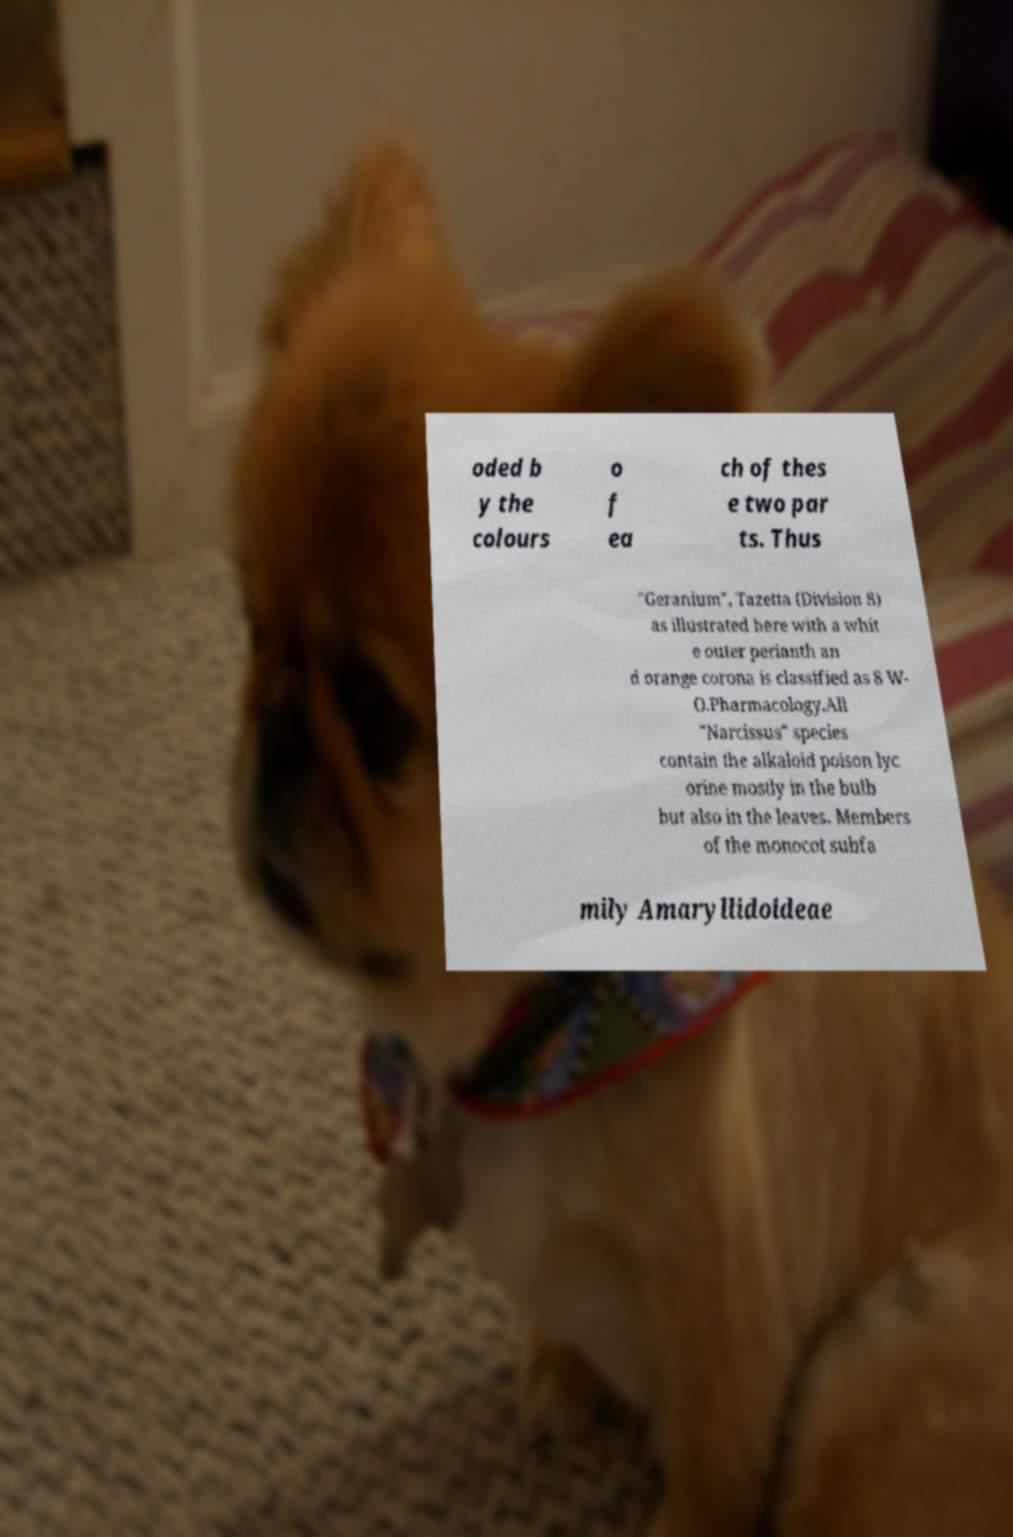Please identify and transcribe the text found in this image. oded b y the colours o f ea ch of thes e two par ts. Thus "Geranium", Tazetta (Division 8) as illustrated here with a whit e outer perianth an d orange corona is classified as 8 W- O.Pharmacology.All "Narcissus" species contain the alkaloid poison lyc orine mostly in the bulb but also in the leaves. Members of the monocot subfa mily Amaryllidoideae 